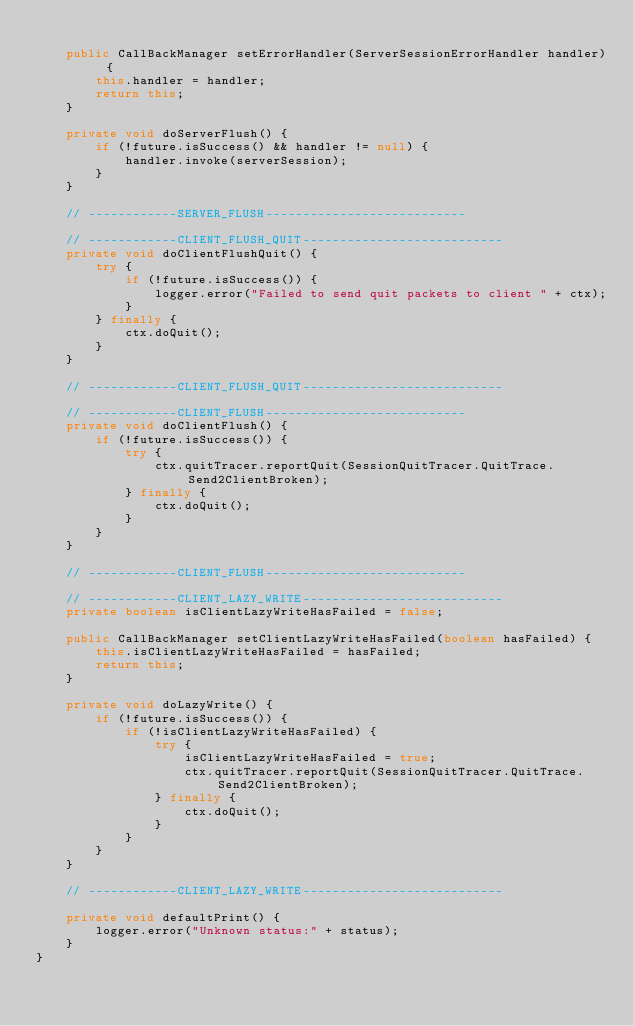<code> <loc_0><loc_0><loc_500><loc_500><_Java_>
    public CallBackManager setErrorHandler(ServerSessionErrorHandler handler) {
        this.handler = handler;
        return this;
    }

    private void doServerFlush() {
        if (!future.isSuccess() && handler != null) {
            handler.invoke(serverSession);
        }
    }

    // ------------SERVER_FLUSH---------------------------

    // ------------CLIENT_FLUSH_QUIT---------------------------
    private void doClientFlushQuit() {
        try {
            if (!future.isSuccess()) {
                logger.error("Failed to send quit packets to client " + ctx);
            }
        } finally {
            ctx.doQuit();
        }
    }

    // ------------CLIENT_FLUSH_QUIT---------------------------

    // ------------CLIENT_FLUSH---------------------------
    private void doClientFlush() {
        if (!future.isSuccess()) {
            try {
                ctx.quitTracer.reportQuit(SessionQuitTracer.QuitTrace.Send2ClientBroken);
            } finally {
                ctx.doQuit();
            }
        }
    }

    // ------------CLIENT_FLUSH---------------------------

    // ------------CLIENT_LAZY_WRITE---------------------------
    private boolean isClientLazyWriteHasFailed = false;

    public CallBackManager setClientLazyWriteHasFailed(boolean hasFailed) {
        this.isClientLazyWriteHasFailed = hasFailed;
        return this;
    }

    private void doLazyWrite() {
        if (!future.isSuccess()) {
            if (!isClientLazyWriteHasFailed) {
                try {
                    isClientLazyWriteHasFailed = true;
                    ctx.quitTracer.reportQuit(SessionQuitTracer.QuitTrace.Send2ClientBroken);
                } finally {
                    ctx.doQuit();
                }
            }
        }
    }

    // ------------CLIENT_LAZY_WRITE---------------------------

    private void defaultPrint() {
        logger.error("Unknown status:" + status);
    }
}
</code> 